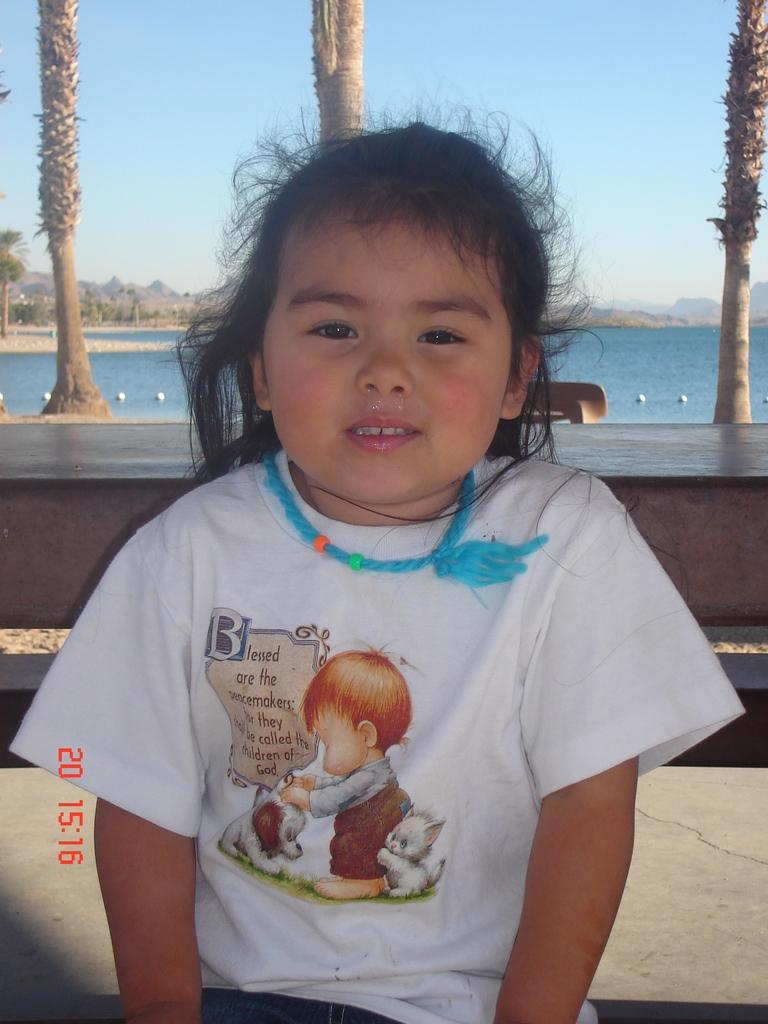Who is the main subject in the image? There is a girl in the image. What is the girl wearing? The girl is wearing a white dress. What type of natural environment can be seen in the image? Trees and the sea are visible in the image. What part of the trees can be seen in the image? Tree barks are present in the image. What type of quiver can be seen hanging from the girl's shoulder in the image? There is no quiver present in the image; the girl is wearing a white dress and there are trees and the sea visible in the background. 